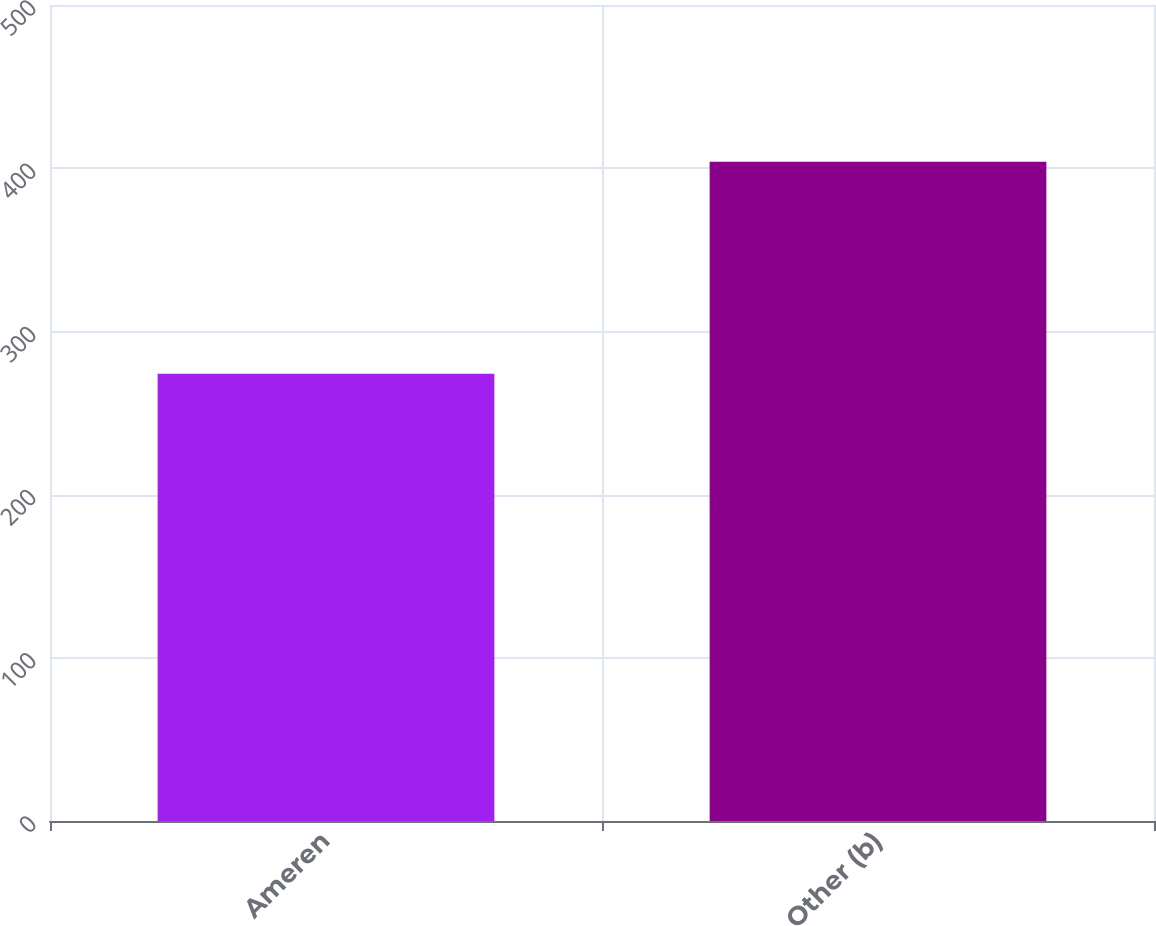Convert chart. <chart><loc_0><loc_0><loc_500><loc_500><bar_chart><fcel>Ameren<fcel>Other (b)<nl><fcel>274<fcel>404<nl></chart> 